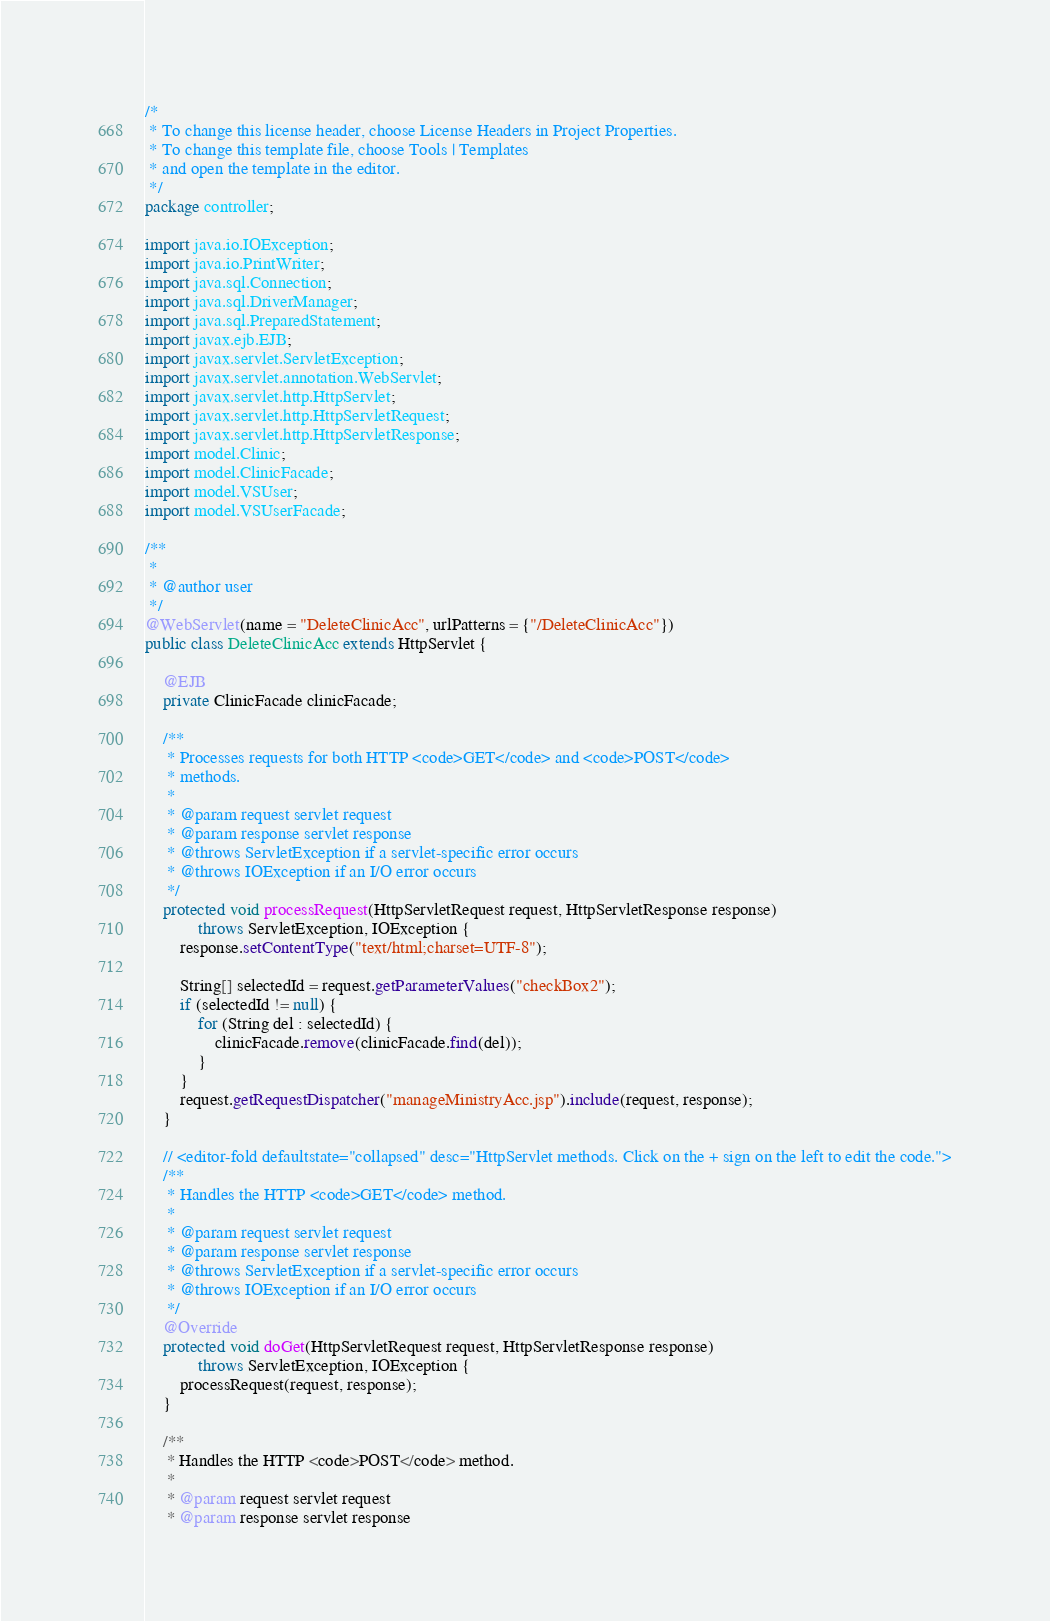<code> <loc_0><loc_0><loc_500><loc_500><_Java_>/*
 * To change this license header, choose License Headers in Project Properties.
 * To change this template file, choose Tools | Templates
 * and open the template in the editor.
 */
package controller;

import java.io.IOException;
import java.io.PrintWriter;
import java.sql.Connection;
import java.sql.DriverManager;
import java.sql.PreparedStatement;
import javax.ejb.EJB;
import javax.servlet.ServletException;
import javax.servlet.annotation.WebServlet;
import javax.servlet.http.HttpServlet;
import javax.servlet.http.HttpServletRequest;
import javax.servlet.http.HttpServletResponse;
import model.Clinic;
import model.ClinicFacade;
import model.VSUser;
import model.VSUserFacade;

/**
 *
 * @author user
 */
@WebServlet(name = "DeleteClinicAcc", urlPatterns = {"/DeleteClinicAcc"})
public class DeleteClinicAcc extends HttpServlet {

    @EJB
    private ClinicFacade clinicFacade;

    /**
     * Processes requests for both HTTP <code>GET</code> and <code>POST</code>
     * methods.
     *
     * @param request servlet request
     * @param response servlet response
     * @throws ServletException if a servlet-specific error occurs
     * @throws IOException if an I/O error occurs
     */
    protected void processRequest(HttpServletRequest request, HttpServletResponse response)
            throws ServletException, IOException {
        response.setContentType("text/html;charset=UTF-8");

        String[] selectedId = request.getParameterValues("checkBox2");
        if (selectedId != null) {
            for (String del : selectedId) {
                clinicFacade.remove(clinicFacade.find(del));
            }
        }
        request.getRequestDispatcher("manageMinistryAcc.jsp").include(request, response);
    }

    // <editor-fold defaultstate="collapsed" desc="HttpServlet methods. Click on the + sign on the left to edit the code.">
    /**
     * Handles the HTTP <code>GET</code> method.
     *
     * @param request servlet request
     * @param response servlet response
     * @throws ServletException if a servlet-specific error occurs
     * @throws IOException if an I/O error occurs
     */
    @Override
    protected void doGet(HttpServletRequest request, HttpServletResponse response)
            throws ServletException, IOException {
        processRequest(request, response);
    }

    /**
     * Handles the HTTP <code>POST</code> method.
     *
     * @param request servlet request
     * @param response servlet response</code> 